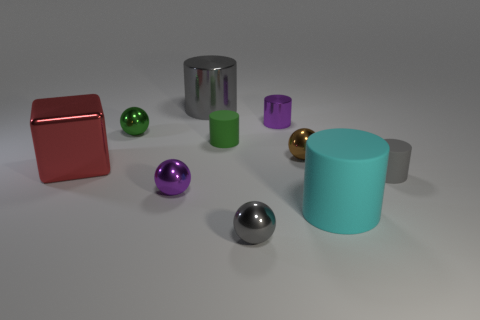Subtract all tiny green balls. How many balls are left? 3 Subtract all gray cylinders. How many cylinders are left? 3 Subtract 1 cylinders. How many cylinders are left? 4 Subtract all cubes. How many objects are left? 9 Subtract all red spheres. Subtract all green cylinders. How many spheres are left? 4 Subtract all green blocks. How many purple cylinders are left? 1 Add 6 large things. How many large things are left? 9 Add 9 gray metallic cylinders. How many gray metallic cylinders exist? 10 Subtract 1 gray balls. How many objects are left? 9 Subtract all red rubber objects. Subtract all big shiny cylinders. How many objects are left? 9 